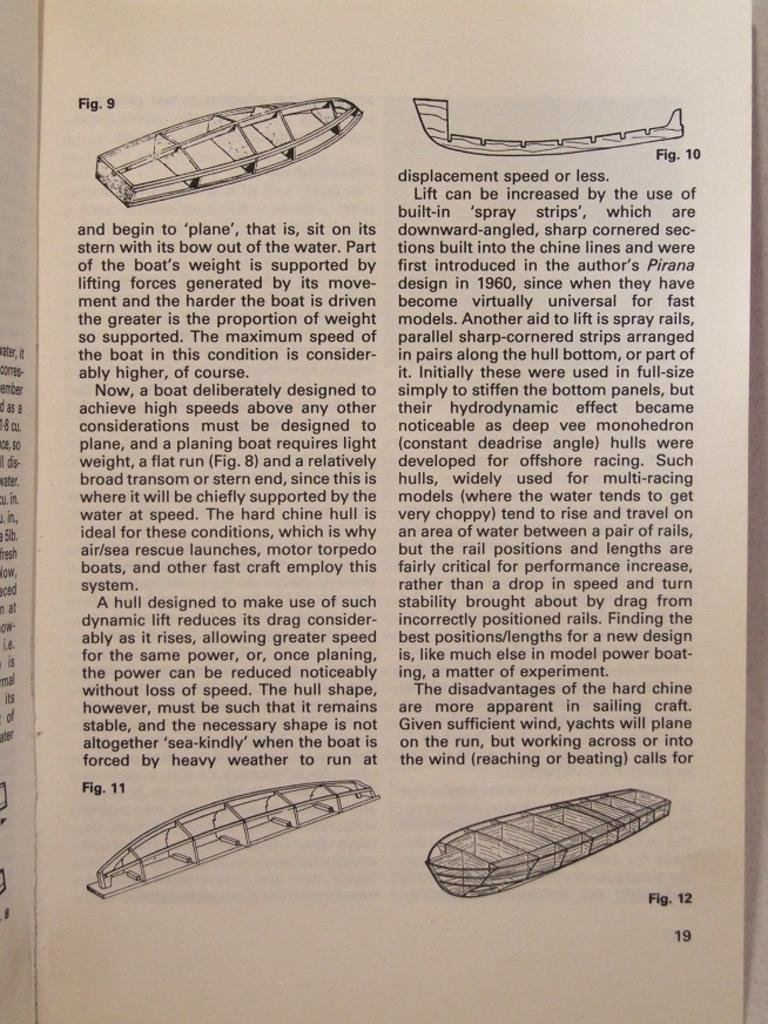How would you summarize this image in a sentence or two? In this image, we can see a paper contains depiction of boats and some text. 